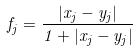<formula> <loc_0><loc_0><loc_500><loc_500>f _ { j } = \frac { | x _ { j } - y _ { j } | } { 1 + | x _ { j } - y _ { j } | }</formula> 